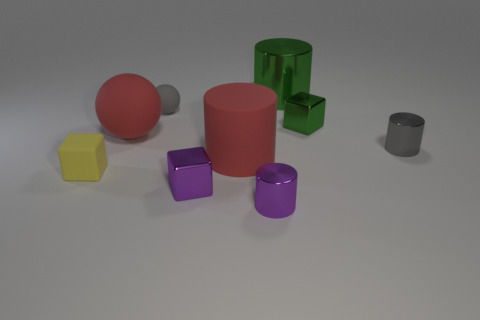Add 1 balls. How many objects exist? 10 Subtract all cylinders. How many objects are left? 5 Subtract all small shiny blocks. Subtract all gray cylinders. How many objects are left? 6 Add 8 large red rubber cylinders. How many large red rubber cylinders are left? 9 Add 2 large metal objects. How many large metal objects exist? 3 Subtract 0 yellow cylinders. How many objects are left? 9 